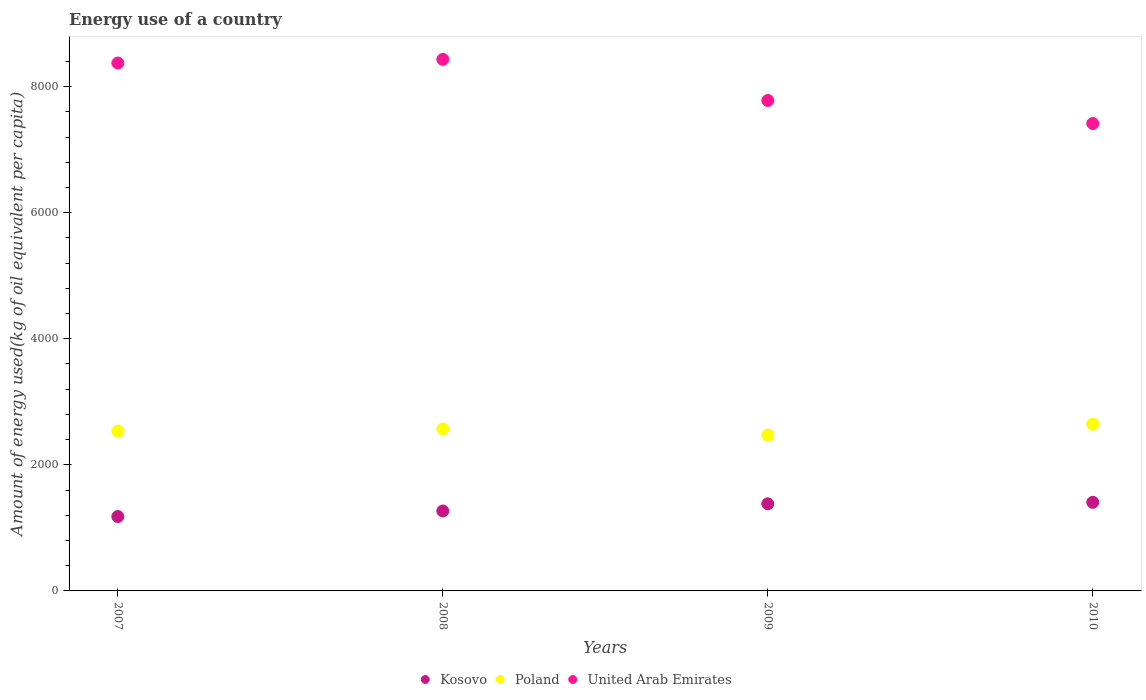How many different coloured dotlines are there?
Give a very brief answer. 3. What is the amount of energy used in in United Arab Emirates in 2010?
Your response must be concise. 7414.66. Across all years, what is the maximum amount of energy used in in United Arab Emirates?
Give a very brief answer. 8431.67. Across all years, what is the minimum amount of energy used in in Kosovo?
Give a very brief answer. 1179.76. What is the total amount of energy used in in Poland in the graph?
Your answer should be very brief. 1.02e+04. What is the difference between the amount of energy used in in United Arab Emirates in 2007 and that in 2009?
Provide a short and direct response. 594.09. What is the difference between the amount of energy used in in United Arab Emirates in 2009 and the amount of energy used in in Kosovo in 2008?
Make the answer very short. 6512.16. What is the average amount of energy used in in Poland per year?
Provide a short and direct response. 2555.3. In the year 2007, what is the difference between the amount of energy used in in Poland and amount of energy used in in United Arab Emirates?
Provide a succinct answer. -5839.32. What is the ratio of the amount of energy used in in Kosovo in 2007 to that in 2010?
Your answer should be compact. 0.84. Is the amount of energy used in in United Arab Emirates in 2008 less than that in 2010?
Offer a very short reply. No. What is the difference between the highest and the second highest amount of energy used in in United Arab Emirates?
Your answer should be very brief. 57.23. What is the difference between the highest and the lowest amount of energy used in in Poland?
Give a very brief answer. 173.2. In how many years, is the amount of energy used in in Kosovo greater than the average amount of energy used in in Kosovo taken over all years?
Your response must be concise. 2. Is the amount of energy used in in Kosovo strictly less than the amount of energy used in in United Arab Emirates over the years?
Provide a succinct answer. Yes. What is the difference between two consecutive major ticks on the Y-axis?
Give a very brief answer. 2000. Are the values on the major ticks of Y-axis written in scientific E-notation?
Offer a very short reply. No. Does the graph contain any zero values?
Give a very brief answer. No. How many legend labels are there?
Provide a short and direct response. 3. How are the legend labels stacked?
Keep it short and to the point. Horizontal. What is the title of the graph?
Your response must be concise. Energy use of a country. What is the label or title of the X-axis?
Your response must be concise. Years. What is the label or title of the Y-axis?
Keep it short and to the point. Amount of energy used(kg of oil equivalent per capita). What is the Amount of energy used(kg of oil equivalent per capita) in Kosovo in 2007?
Make the answer very short. 1179.76. What is the Amount of energy used(kg of oil equivalent per capita) in Poland in 2007?
Your response must be concise. 2535.12. What is the Amount of energy used(kg of oil equivalent per capita) in United Arab Emirates in 2007?
Offer a terse response. 8374.44. What is the Amount of energy used(kg of oil equivalent per capita) in Kosovo in 2008?
Keep it short and to the point. 1268.2. What is the Amount of energy used(kg of oil equivalent per capita) in Poland in 2008?
Offer a very short reply. 2569.22. What is the Amount of energy used(kg of oil equivalent per capita) in United Arab Emirates in 2008?
Your answer should be compact. 8431.67. What is the Amount of energy used(kg of oil equivalent per capita) of Kosovo in 2009?
Provide a succinct answer. 1382.43. What is the Amount of energy used(kg of oil equivalent per capita) of Poland in 2009?
Provide a succinct answer. 2471.83. What is the Amount of energy used(kg of oil equivalent per capita) of United Arab Emirates in 2009?
Make the answer very short. 7780.36. What is the Amount of energy used(kg of oil equivalent per capita) in Kosovo in 2010?
Keep it short and to the point. 1405.52. What is the Amount of energy used(kg of oil equivalent per capita) in Poland in 2010?
Your response must be concise. 2645.03. What is the Amount of energy used(kg of oil equivalent per capita) of United Arab Emirates in 2010?
Provide a succinct answer. 7414.66. Across all years, what is the maximum Amount of energy used(kg of oil equivalent per capita) in Kosovo?
Your answer should be very brief. 1405.52. Across all years, what is the maximum Amount of energy used(kg of oil equivalent per capita) in Poland?
Provide a short and direct response. 2645.03. Across all years, what is the maximum Amount of energy used(kg of oil equivalent per capita) in United Arab Emirates?
Make the answer very short. 8431.67. Across all years, what is the minimum Amount of energy used(kg of oil equivalent per capita) of Kosovo?
Your answer should be very brief. 1179.76. Across all years, what is the minimum Amount of energy used(kg of oil equivalent per capita) in Poland?
Your answer should be compact. 2471.83. Across all years, what is the minimum Amount of energy used(kg of oil equivalent per capita) of United Arab Emirates?
Your response must be concise. 7414.66. What is the total Amount of energy used(kg of oil equivalent per capita) in Kosovo in the graph?
Your answer should be very brief. 5235.9. What is the total Amount of energy used(kg of oil equivalent per capita) in Poland in the graph?
Make the answer very short. 1.02e+04. What is the total Amount of energy used(kg of oil equivalent per capita) of United Arab Emirates in the graph?
Give a very brief answer. 3.20e+04. What is the difference between the Amount of energy used(kg of oil equivalent per capita) of Kosovo in 2007 and that in 2008?
Your response must be concise. -88.44. What is the difference between the Amount of energy used(kg of oil equivalent per capita) of Poland in 2007 and that in 2008?
Ensure brevity in your answer.  -34.09. What is the difference between the Amount of energy used(kg of oil equivalent per capita) of United Arab Emirates in 2007 and that in 2008?
Offer a very short reply. -57.23. What is the difference between the Amount of energy used(kg of oil equivalent per capita) of Kosovo in 2007 and that in 2009?
Ensure brevity in your answer.  -202.67. What is the difference between the Amount of energy used(kg of oil equivalent per capita) of Poland in 2007 and that in 2009?
Your answer should be very brief. 63.29. What is the difference between the Amount of energy used(kg of oil equivalent per capita) in United Arab Emirates in 2007 and that in 2009?
Provide a short and direct response. 594.09. What is the difference between the Amount of energy used(kg of oil equivalent per capita) in Kosovo in 2007 and that in 2010?
Your answer should be compact. -225.76. What is the difference between the Amount of energy used(kg of oil equivalent per capita) in Poland in 2007 and that in 2010?
Your answer should be compact. -109.9. What is the difference between the Amount of energy used(kg of oil equivalent per capita) in United Arab Emirates in 2007 and that in 2010?
Your response must be concise. 959.79. What is the difference between the Amount of energy used(kg of oil equivalent per capita) in Kosovo in 2008 and that in 2009?
Keep it short and to the point. -114.23. What is the difference between the Amount of energy used(kg of oil equivalent per capita) in Poland in 2008 and that in 2009?
Offer a very short reply. 97.39. What is the difference between the Amount of energy used(kg of oil equivalent per capita) in United Arab Emirates in 2008 and that in 2009?
Provide a succinct answer. 651.31. What is the difference between the Amount of energy used(kg of oil equivalent per capita) in Kosovo in 2008 and that in 2010?
Provide a short and direct response. -137.32. What is the difference between the Amount of energy used(kg of oil equivalent per capita) in Poland in 2008 and that in 2010?
Offer a terse response. -75.81. What is the difference between the Amount of energy used(kg of oil equivalent per capita) of United Arab Emirates in 2008 and that in 2010?
Keep it short and to the point. 1017.01. What is the difference between the Amount of energy used(kg of oil equivalent per capita) in Kosovo in 2009 and that in 2010?
Offer a very short reply. -23.09. What is the difference between the Amount of energy used(kg of oil equivalent per capita) in Poland in 2009 and that in 2010?
Provide a succinct answer. -173.2. What is the difference between the Amount of energy used(kg of oil equivalent per capita) in United Arab Emirates in 2009 and that in 2010?
Your response must be concise. 365.7. What is the difference between the Amount of energy used(kg of oil equivalent per capita) in Kosovo in 2007 and the Amount of energy used(kg of oil equivalent per capita) in Poland in 2008?
Your response must be concise. -1389.46. What is the difference between the Amount of energy used(kg of oil equivalent per capita) of Kosovo in 2007 and the Amount of energy used(kg of oil equivalent per capita) of United Arab Emirates in 2008?
Provide a succinct answer. -7251.91. What is the difference between the Amount of energy used(kg of oil equivalent per capita) in Poland in 2007 and the Amount of energy used(kg of oil equivalent per capita) in United Arab Emirates in 2008?
Your answer should be very brief. -5896.55. What is the difference between the Amount of energy used(kg of oil equivalent per capita) in Kosovo in 2007 and the Amount of energy used(kg of oil equivalent per capita) in Poland in 2009?
Ensure brevity in your answer.  -1292.07. What is the difference between the Amount of energy used(kg of oil equivalent per capita) of Kosovo in 2007 and the Amount of energy used(kg of oil equivalent per capita) of United Arab Emirates in 2009?
Your answer should be compact. -6600.6. What is the difference between the Amount of energy used(kg of oil equivalent per capita) in Poland in 2007 and the Amount of energy used(kg of oil equivalent per capita) in United Arab Emirates in 2009?
Your answer should be very brief. -5245.23. What is the difference between the Amount of energy used(kg of oil equivalent per capita) in Kosovo in 2007 and the Amount of energy used(kg of oil equivalent per capita) in Poland in 2010?
Your answer should be very brief. -1465.27. What is the difference between the Amount of energy used(kg of oil equivalent per capita) in Kosovo in 2007 and the Amount of energy used(kg of oil equivalent per capita) in United Arab Emirates in 2010?
Keep it short and to the point. -6234.9. What is the difference between the Amount of energy used(kg of oil equivalent per capita) in Poland in 2007 and the Amount of energy used(kg of oil equivalent per capita) in United Arab Emirates in 2010?
Provide a short and direct response. -4879.54. What is the difference between the Amount of energy used(kg of oil equivalent per capita) of Kosovo in 2008 and the Amount of energy used(kg of oil equivalent per capita) of Poland in 2009?
Your answer should be compact. -1203.63. What is the difference between the Amount of energy used(kg of oil equivalent per capita) in Kosovo in 2008 and the Amount of energy used(kg of oil equivalent per capita) in United Arab Emirates in 2009?
Your answer should be compact. -6512.16. What is the difference between the Amount of energy used(kg of oil equivalent per capita) of Poland in 2008 and the Amount of energy used(kg of oil equivalent per capita) of United Arab Emirates in 2009?
Make the answer very short. -5211.14. What is the difference between the Amount of energy used(kg of oil equivalent per capita) of Kosovo in 2008 and the Amount of energy used(kg of oil equivalent per capita) of Poland in 2010?
Your answer should be compact. -1376.83. What is the difference between the Amount of energy used(kg of oil equivalent per capita) of Kosovo in 2008 and the Amount of energy used(kg of oil equivalent per capita) of United Arab Emirates in 2010?
Give a very brief answer. -6146.46. What is the difference between the Amount of energy used(kg of oil equivalent per capita) of Poland in 2008 and the Amount of energy used(kg of oil equivalent per capita) of United Arab Emirates in 2010?
Your answer should be compact. -4845.44. What is the difference between the Amount of energy used(kg of oil equivalent per capita) in Kosovo in 2009 and the Amount of energy used(kg of oil equivalent per capita) in Poland in 2010?
Your response must be concise. -1262.6. What is the difference between the Amount of energy used(kg of oil equivalent per capita) of Kosovo in 2009 and the Amount of energy used(kg of oil equivalent per capita) of United Arab Emirates in 2010?
Your answer should be compact. -6032.23. What is the difference between the Amount of energy used(kg of oil equivalent per capita) in Poland in 2009 and the Amount of energy used(kg of oil equivalent per capita) in United Arab Emirates in 2010?
Provide a succinct answer. -4942.83. What is the average Amount of energy used(kg of oil equivalent per capita) of Kosovo per year?
Keep it short and to the point. 1308.98. What is the average Amount of energy used(kg of oil equivalent per capita) in Poland per year?
Your answer should be very brief. 2555.3. What is the average Amount of energy used(kg of oil equivalent per capita) in United Arab Emirates per year?
Keep it short and to the point. 8000.28. In the year 2007, what is the difference between the Amount of energy used(kg of oil equivalent per capita) in Kosovo and Amount of energy used(kg of oil equivalent per capita) in Poland?
Provide a succinct answer. -1355.36. In the year 2007, what is the difference between the Amount of energy used(kg of oil equivalent per capita) of Kosovo and Amount of energy used(kg of oil equivalent per capita) of United Arab Emirates?
Your response must be concise. -7194.69. In the year 2007, what is the difference between the Amount of energy used(kg of oil equivalent per capita) of Poland and Amount of energy used(kg of oil equivalent per capita) of United Arab Emirates?
Provide a short and direct response. -5839.32. In the year 2008, what is the difference between the Amount of energy used(kg of oil equivalent per capita) in Kosovo and Amount of energy used(kg of oil equivalent per capita) in Poland?
Keep it short and to the point. -1301.02. In the year 2008, what is the difference between the Amount of energy used(kg of oil equivalent per capita) in Kosovo and Amount of energy used(kg of oil equivalent per capita) in United Arab Emirates?
Your answer should be very brief. -7163.47. In the year 2008, what is the difference between the Amount of energy used(kg of oil equivalent per capita) of Poland and Amount of energy used(kg of oil equivalent per capita) of United Arab Emirates?
Ensure brevity in your answer.  -5862.45. In the year 2009, what is the difference between the Amount of energy used(kg of oil equivalent per capita) of Kosovo and Amount of energy used(kg of oil equivalent per capita) of Poland?
Provide a short and direct response. -1089.41. In the year 2009, what is the difference between the Amount of energy used(kg of oil equivalent per capita) of Kosovo and Amount of energy used(kg of oil equivalent per capita) of United Arab Emirates?
Offer a very short reply. -6397.93. In the year 2009, what is the difference between the Amount of energy used(kg of oil equivalent per capita) of Poland and Amount of energy used(kg of oil equivalent per capita) of United Arab Emirates?
Ensure brevity in your answer.  -5308.52. In the year 2010, what is the difference between the Amount of energy used(kg of oil equivalent per capita) in Kosovo and Amount of energy used(kg of oil equivalent per capita) in Poland?
Ensure brevity in your answer.  -1239.51. In the year 2010, what is the difference between the Amount of energy used(kg of oil equivalent per capita) in Kosovo and Amount of energy used(kg of oil equivalent per capita) in United Arab Emirates?
Provide a short and direct response. -6009.14. In the year 2010, what is the difference between the Amount of energy used(kg of oil equivalent per capita) of Poland and Amount of energy used(kg of oil equivalent per capita) of United Arab Emirates?
Provide a short and direct response. -4769.63. What is the ratio of the Amount of energy used(kg of oil equivalent per capita) in Kosovo in 2007 to that in 2008?
Provide a short and direct response. 0.93. What is the ratio of the Amount of energy used(kg of oil equivalent per capita) in Poland in 2007 to that in 2008?
Keep it short and to the point. 0.99. What is the ratio of the Amount of energy used(kg of oil equivalent per capita) in United Arab Emirates in 2007 to that in 2008?
Ensure brevity in your answer.  0.99. What is the ratio of the Amount of energy used(kg of oil equivalent per capita) of Kosovo in 2007 to that in 2009?
Ensure brevity in your answer.  0.85. What is the ratio of the Amount of energy used(kg of oil equivalent per capita) of Poland in 2007 to that in 2009?
Offer a very short reply. 1.03. What is the ratio of the Amount of energy used(kg of oil equivalent per capita) in United Arab Emirates in 2007 to that in 2009?
Offer a very short reply. 1.08. What is the ratio of the Amount of energy used(kg of oil equivalent per capita) in Kosovo in 2007 to that in 2010?
Your answer should be very brief. 0.84. What is the ratio of the Amount of energy used(kg of oil equivalent per capita) in Poland in 2007 to that in 2010?
Your response must be concise. 0.96. What is the ratio of the Amount of energy used(kg of oil equivalent per capita) of United Arab Emirates in 2007 to that in 2010?
Make the answer very short. 1.13. What is the ratio of the Amount of energy used(kg of oil equivalent per capita) of Kosovo in 2008 to that in 2009?
Offer a very short reply. 0.92. What is the ratio of the Amount of energy used(kg of oil equivalent per capita) of Poland in 2008 to that in 2009?
Keep it short and to the point. 1.04. What is the ratio of the Amount of energy used(kg of oil equivalent per capita) in United Arab Emirates in 2008 to that in 2009?
Keep it short and to the point. 1.08. What is the ratio of the Amount of energy used(kg of oil equivalent per capita) of Kosovo in 2008 to that in 2010?
Offer a very short reply. 0.9. What is the ratio of the Amount of energy used(kg of oil equivalent per capita) of Poland in 2008 to that in 2010?
Your answer should be very brief. 0.97. What is the ratio of the Amount of energy used(kg of oil equivalent per capita) in United Arab Emirates in 2008 to that in 2010?
Your response must be concise. 1.14. What is the ratio of the Amount of energy used(kg of oil equivalent per capita) in Kosovo in 2009 to that in 2010?
Offer a terse response. 0.98. What is the ratio of the Amount of energy used(kg of oil equivalent per capita) of Poland in 2009 to that in 2010?
Offer a very short reply. 0.93. What is the ratio of the Amount of energy used(kg of oil equivalent per capita) of United Arab Emirates in 2009 to that in 2010?
Your answer should be very brief. 1.05. What is the difference between the highest and the second highest Amount of energy used(kg of oil equivalent per capita) of Kosovo?
Your answer should be compact. 23.09. What is the difference between the highest and the second highest Amount of energy used(kg of oil equivalent per capita) of Poland?
Your answer should be compact. 75.81. What is the difference between the highest and the second highest Amount of energy used(kg of oil equivalent per capita) of United Arab Emirates?
Offer a very short reply. 57.23. What is the difference between the highest and the lowest Amount of energy used(kg of oil equivalent per capita) in Kosovo?
Offer a terse response. 225.76. What is the difference between the highest and the lowest Amount of energy used(kg of oil equivalent per capita) in Poland?
Ensure brevity in your answer.  173.2. What is the difference between the highest and the lowest Amount of energy used(kg of oil equivalent per capita) in United Arab Emirates?
Your response must be concise. 1017.01. 